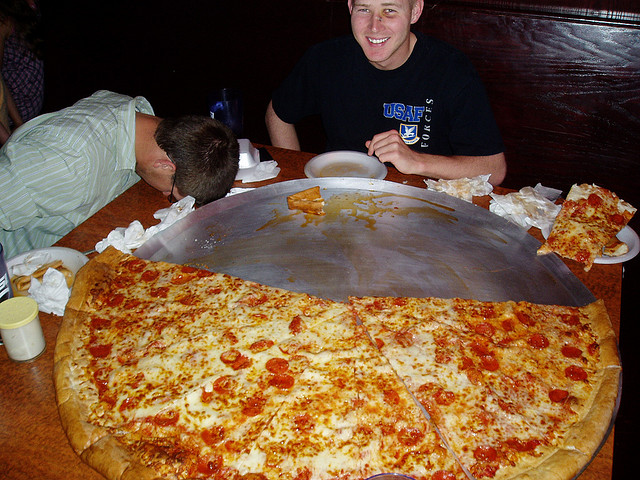Please extract the text content from this image. USAF FOKCES 